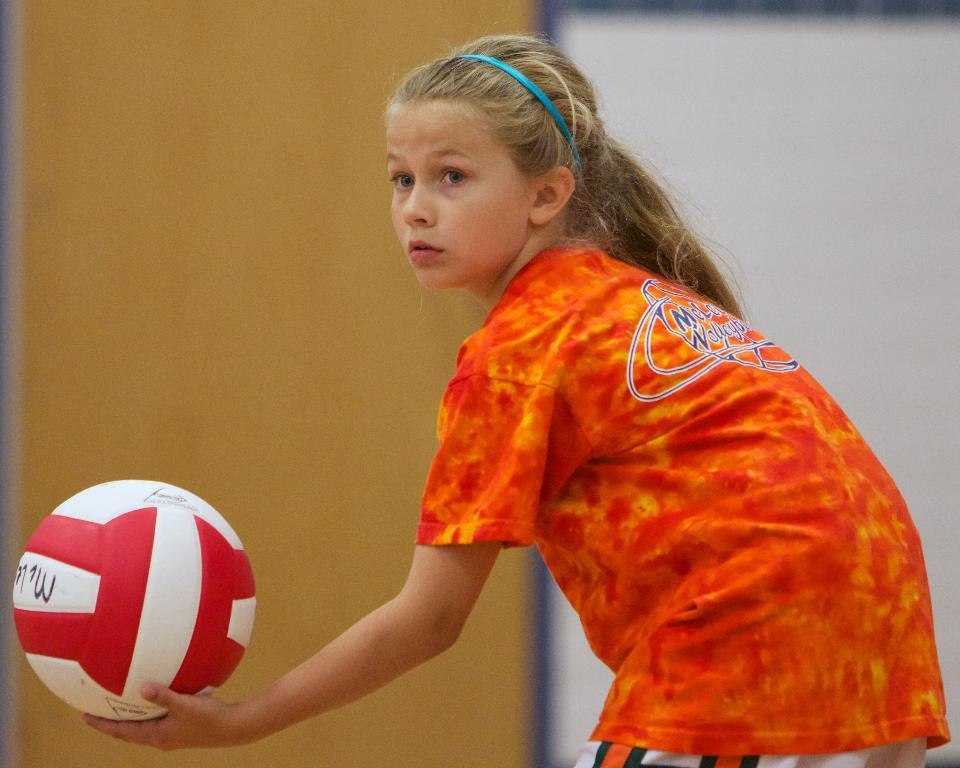Who is the main subject in the image? There is a girl in the image. What is the girl holding in the image? The girl is holding a ball. What type of sheet is the girl using to cover the babies in the image? There are no babies or sheets present in the image. What health benefits does the girl receive from holding the ball in the image? The image does not provide information about any health benefits associated with holding the ball. 